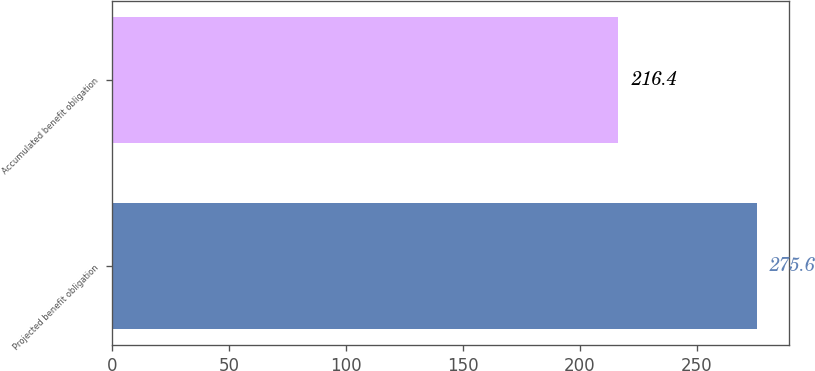Convert chart to OTSL. <chart><loc_0><loc_0><loc_500><loc_500><bar_chart><fcel>Projected benefit obligation<fcel>Accumulated benefit obligation<nl><fcel>275.6<fcel>216.4<nl></chart> 